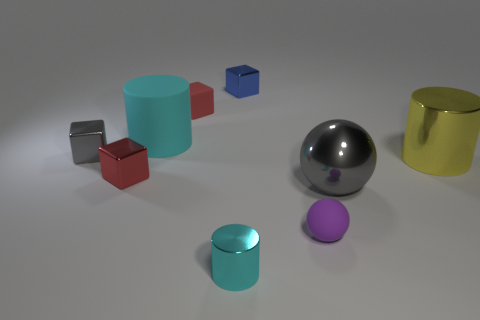Subtract all balls. How many objects are left? 7 Add 5 large rubber things. How many large rubber things are left? 6 Add 9 tiny brown metal cubes. How many tiny brown metal cubes exist? 9 Subtract 0 blue cylinders. How many objects are left? 9 Subtract all small gray blocks. Subtract all big yellow things. How many objects are left? 7 